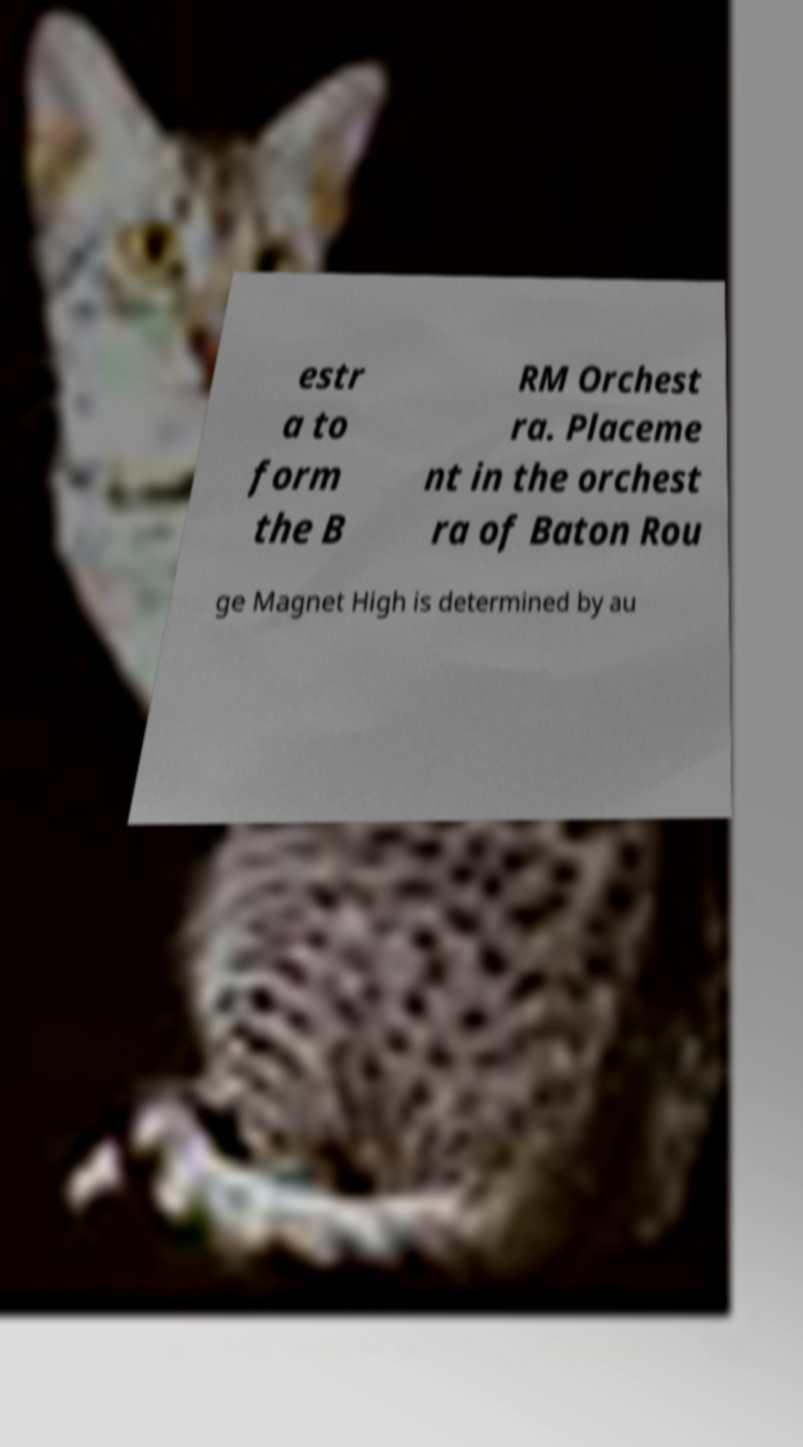There's text embedded in this image that I need extracted. Can you transcribe it verbatim? estr a to form the B RM Orchest ra. Placeme nt in the orchest ra of Baton Rou ge Magnet High is determined by au 